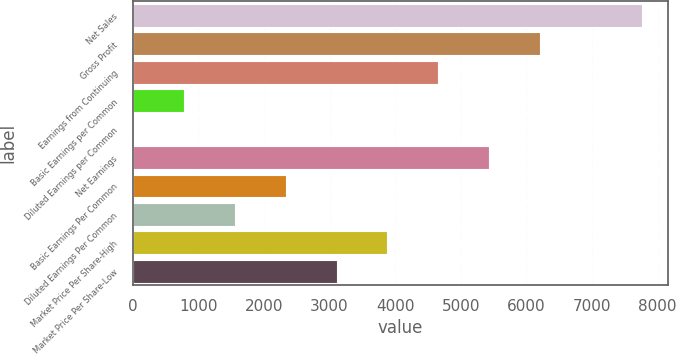Convert chart. <chart><loc_0><loc_0><loc_500><loc_500><bar_chart><fcel>Net Sales<fcel>Gross Profit<fcel>Earnings from Continuing<fcel>Basic Earnings per Common<fcel>Diluted Earnings per Common<fcel>Net Earnings<fcel>Basic Earnings Per Common<fcel>Diluted Earnings Per Common<fcel>Market Price Per Share-High<fcel>Market Price Per Share-Low<nl><fcel>7767<fcel>6213.68<fcel>4660.36<fcel>777.06<fcel>0.4<fcel>5437.02<fcel>2330.38<fcel>1553.72<fcel>3883.7<fcel>3107.04<nl></chart> 